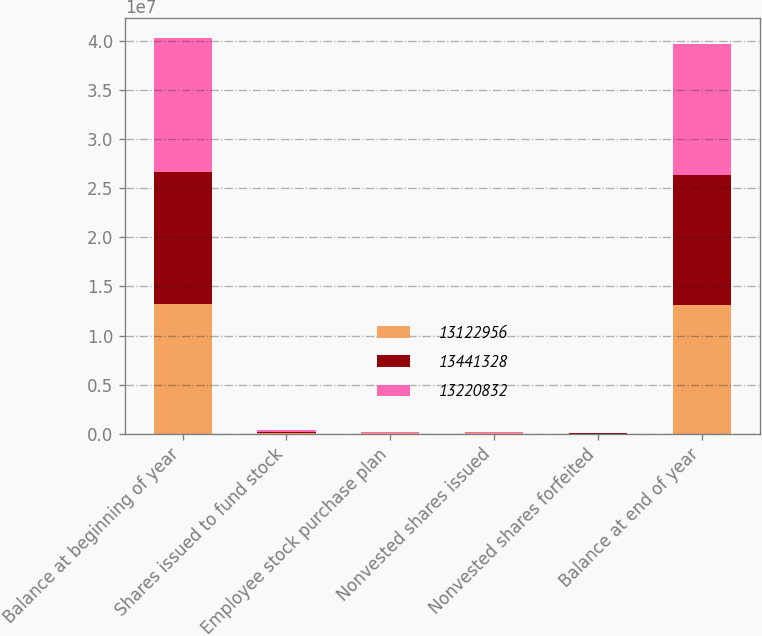<chart> <loc_0><loc_0><loc_500><loc_500><stacked_bar_chart><ecel><fcel>Balance at beginning of year<fcel>Shares issued to fund stock<fcel>Employee stock purchase plan<fcel>Nonvested shares issued<fcel>Nonvested shares forfeited<fcel>Balance at end of year<nl><fcel>1.3123e+07<fcel>1.32208e+07<fcel>54209<fcel>42391<fcel>5723<fcel>4447<fcel>1.3123e+07<nl><fcel>1.34413e+07<fcel>1.34413e+07<fcel>141728<fcel>44319<fcel>56136<fcel>21687<fcel>1.32208e+07<nl><fcel>1.32208e+07<fcel>1.37035e+07<fcel>158440<fcel>59390<fcel>57659<fcel>13364<fcel>1.34413e+07<nl></chart> 